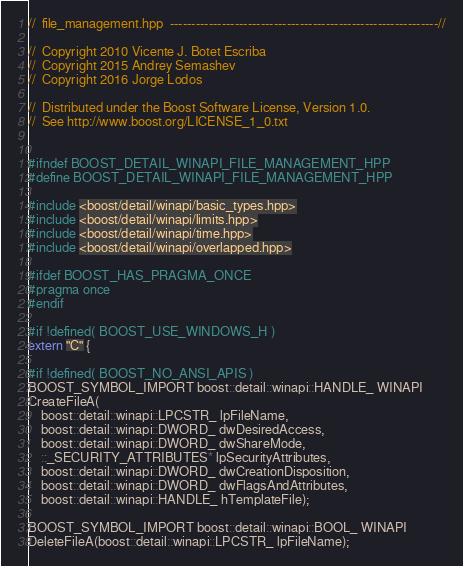<code> <loc_0><loc_0><loc_500><loc_500><_C++_>//  file_management.hpp  --------------------------------------------------------------//

//  Copyright 2010 Vicente J. Botet Escriba
//  Copyright 2015 Andrey Semashev
//  Copyright 2016 Jorge Lodos

//  Distributed under the Boost Software License, Version 1.0.
//  See http://www.boost.org/LICENSE_1_0.txt


#ifndef BOOST_DETAIL_WINAPI_FILE_MANAGEMENT_HPP
#define BOOST_DETAIL_WINAPI_FILE_MANAGEMENT_HPP

#include <boost/detail/winapi/basic_types.hpp>
#include <boost/detail/winapi/limits.hpp>
#include <boost/detail/winapi/time.hpp>
#include <boost/detail/winapi/overlapped.hpp>

#ifdef BOOST_HAS_PRAGMA_ONCE
#pragma once
#endif

#if !defined( BOOST_USE_WINDOWS_H )
extern "C" {

#if !defined( BOOST_NO_ANSI_APIS )
BOOST_SYMBOL_IMPORT boost::detail::winapi::HANDLE_ WINAPI
CreateFileA(
    boost::detail::winapi::LPCSTR_ lpFileName,
    boost::detail::winapi::DWORD_ dwDesiredAccess,
    boost::detail::winapi::DWORD_ dwShareMode,
    ::_SECURITY_ATTRIBUTES* lpSecurityAttributes,
    boost::detail::winapi::DWORD_ dwCreationDisposition,
    boost::detail::winapi::DWORD_ dwFlagsAndAttributes,
    boost::detail::winapi::HANDLE_ hTemplateFile);

BOOST_SYMBOL_IMPORT boost::detail::winapi::BOOL_ WINAPI
DeleteFileA(boost::detail::winapi::LPCSTR_ lpFileName);
</code> 